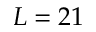Convert formula to latex. <formula><loc_0><loc_0><loc_500><loc_500>L = 2 1</formula> 